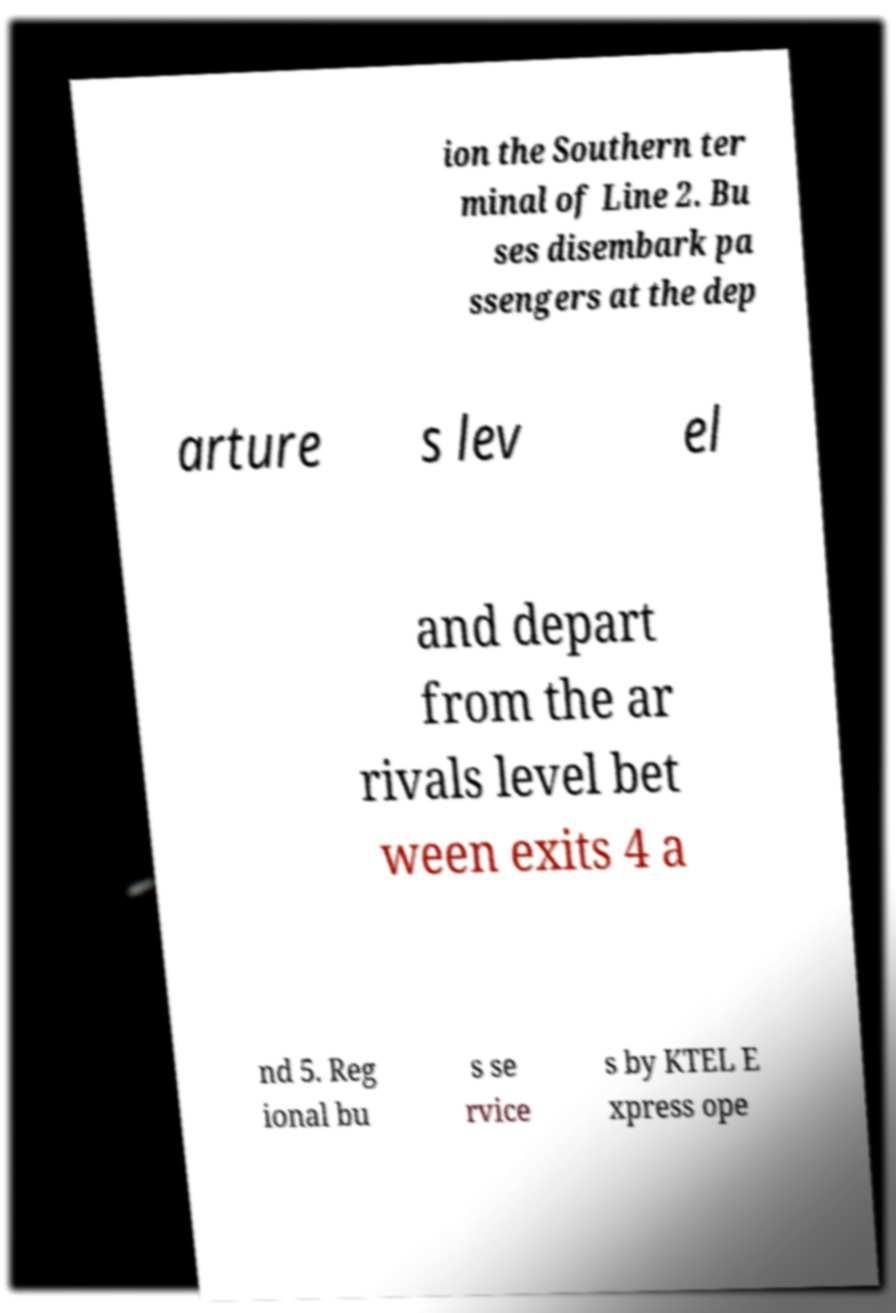I need the written content from this picture converted into text. Can you do that? ion the Southern ter minal of Line 2. Bu ses disembark pa ssengers at the dep arture s lev el and depart from the ar rivals level bet ween exits 4 a nd 5. Reg ional bu s se rvice s by KTEL E xpress ope 